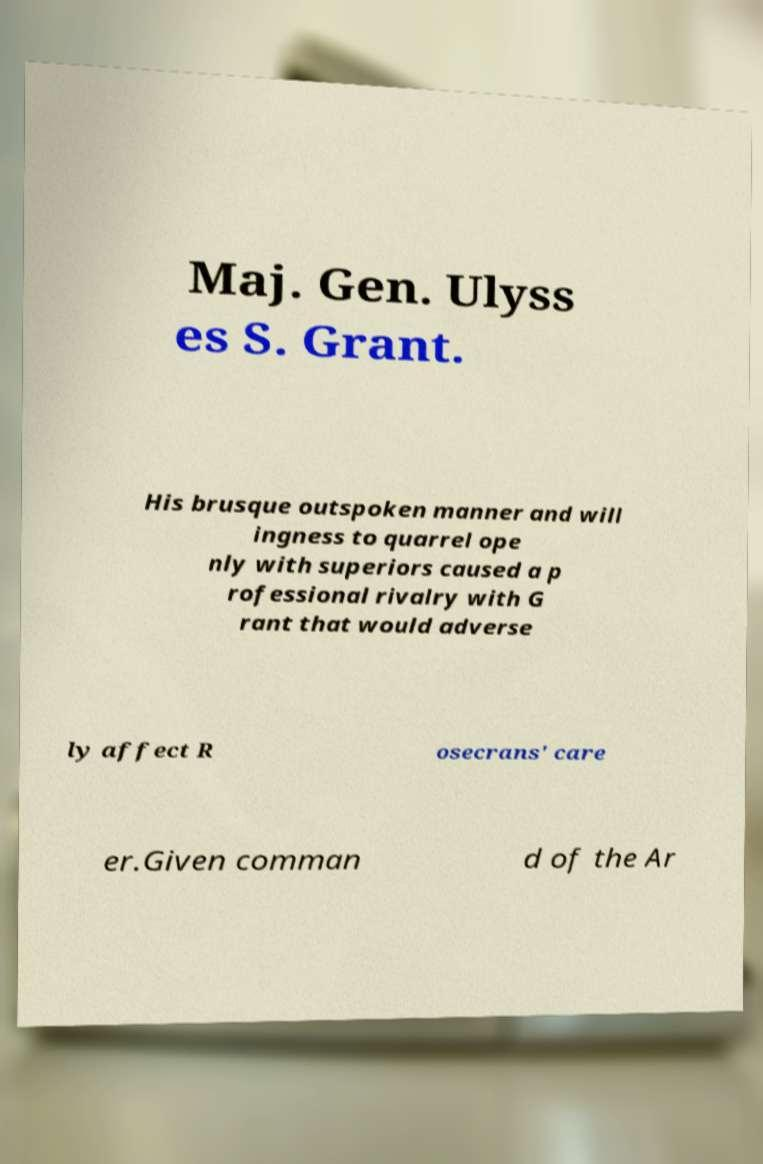Can you read and provide the text displayed in the image?This photo seems to have some interesting text. Can you extract and type it out for me? Maj. Gen. Ulyss es S. Grant. His brusque outspoken manner and will ingness to quarrel ope nly with superiors caused a p rofessional rivalry with G rant that would adverse ly affect R osecrans' care er.Given comman d of the Ar 